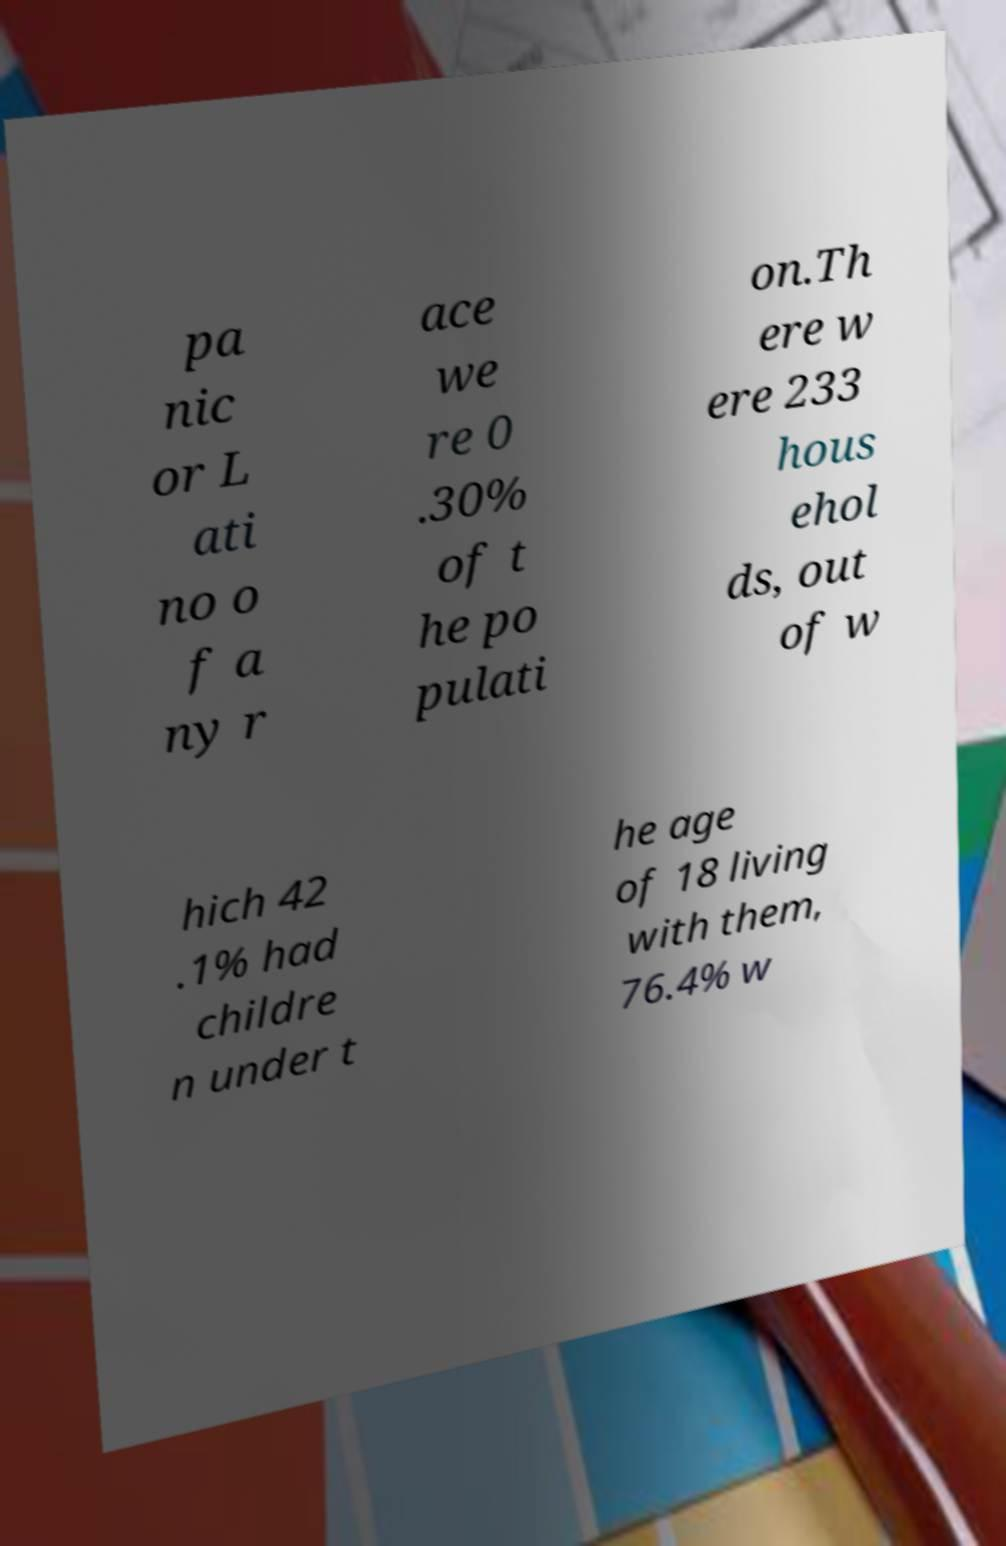Could you extract and type out the text from this image? pa nic or L ati no o f a ny r ace we re 0 .30% of t he po pulati on.Th ere w ere 233 hous ehol ds, out of w hich 42 .1% had childre n under t he age of 18 living with them, 76.4% w 